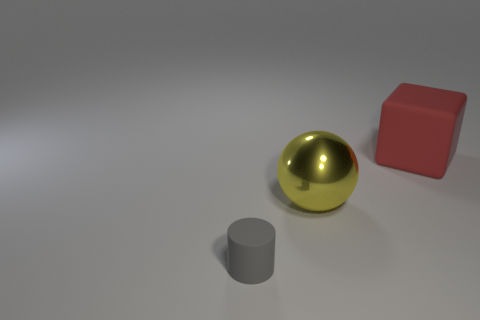What number of objects are green blocks or things in front of the rubber cube?
Your response must be concise. 2. There is a yellow sphere that is the same size as the red block; what is its material?
Make the answer very short. Metal. Does the large red object have the same material as the gray object?
Give a very brief answer. Yes. There is a thing that is both to the right of the small gray thing and to the left of the red matte cube; what is its color?
Give a very brief answer. Yellow. What is the shape of the rubber thing that is the same size as the yellow metal sphere?
Offer a terse response. Cube. What number of other objects are there of the same color as the large rubber cube?
Your response must be concise. 0. What number of other objects are the same material as the large yellow ball?
Provide a short and direct response. 0. There is a gray matte object; is its size the same as the matte thing that is right of the tiny gray cylinder?
Your answer should be compact. No. What color is the sphere?
Your answer should be very brief. Yellow. The rubber object that is behind the object that is in front of the big object that is left of the big rubber block is what shape?
Make the answer very short. Cube. 